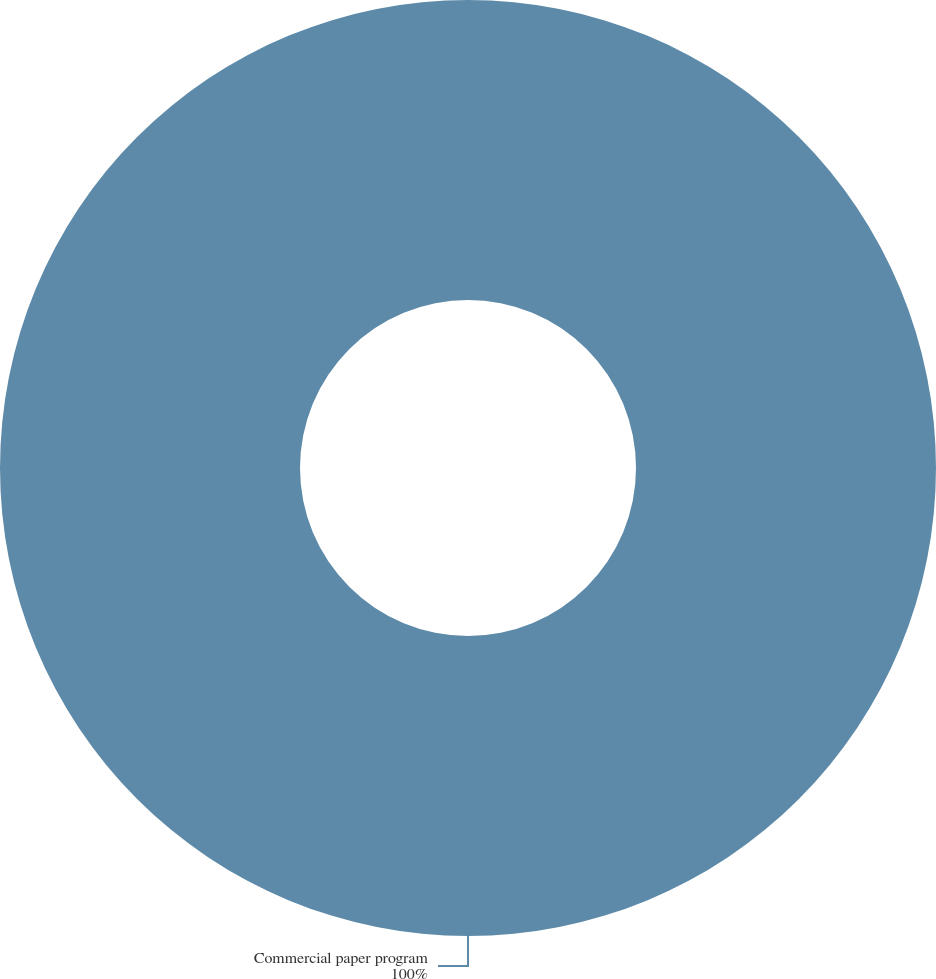Convert chart to OTSL. <chart><loc_0><loc_0><loc_500><loc_500><pie_chart><fcel>Commercial paper program<nl><fcel>100.0%<nl></chart> 